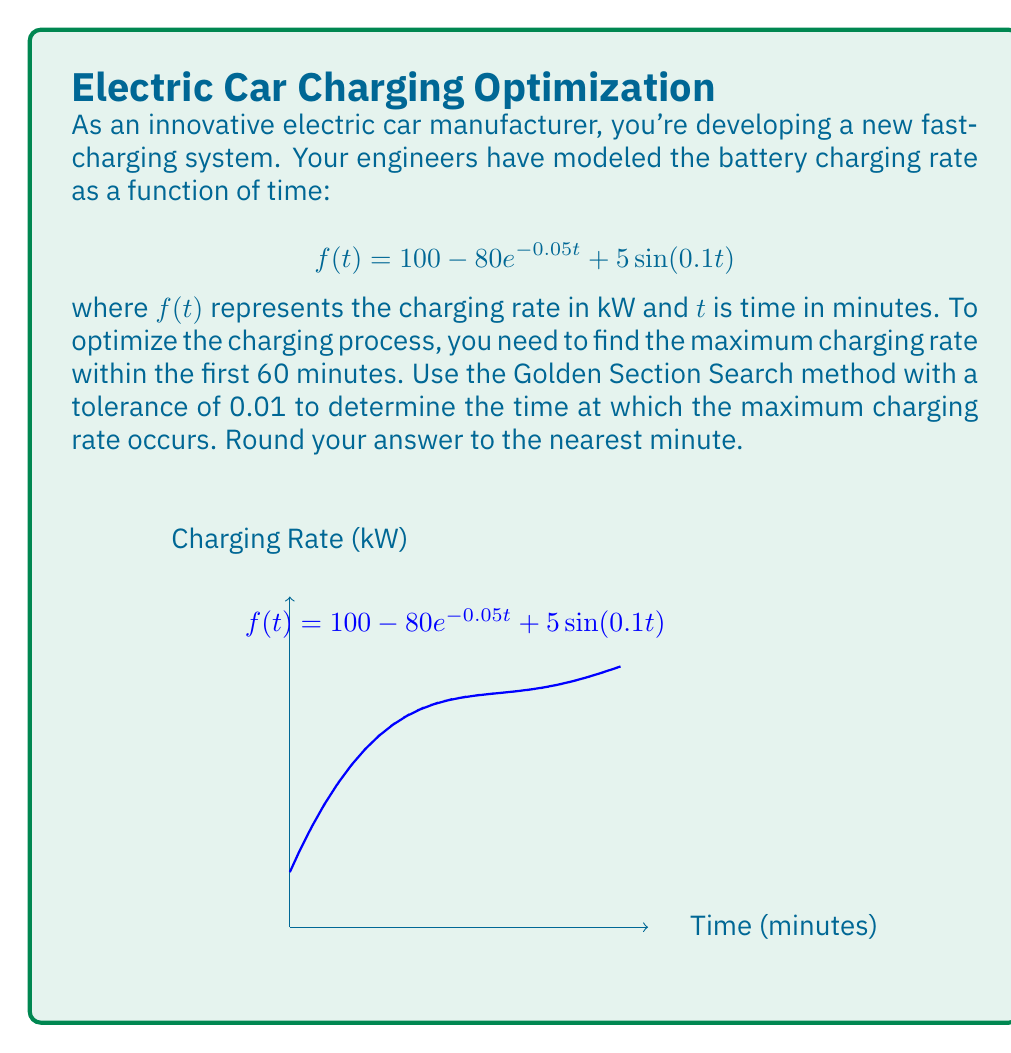What is the answer to this math problem? To solve this problem, we'll use the Golden Section Search method to find the maximum of the function $f(t) = 100 - 80e^{-0.05t} + 5\sin(0.1t)$ in the interval $[0, 60]$.

The Golden ratio, $\phi = \frac{\sqrt{5} - 1}{2} \approx 0.618$, is used to determine the search intervals.

Step 1: Initialize the search interval
$a = 0$, $b = 60$

Step 2: Calculate initial points
$x_1 = b - \phi(b-a) = 60 - 0.618 * 60 = 22.92$
$x_2 = a + \phi(b-a) = 0 + 0.618 * 60 = 37.08$

Step 3: Evaluate the function at $x_1$ and $x_2$
$f(x_1) = f(22.92) = 96.7629$
$f(x_2) = f(37.08) = 98.9181$

Step 4: Iterate until $(b-a) < \text{tolerance}$

Iteration 1:
Since $f(x_2) > f(x_1)$, the maximum is in $[x_1, b]$
New interval: $a = 22.92$, $b = 60$
$x_1 = 37.08$, $x_2 = 45.84$
$f(x_1) = 98.9181$, $f(x_2) = 99.6741$

Iteration 2:
$f(x_2) > f(x_1)$, so new interval: $a = 37.08$, $b = 60$
$x_1 = 45.84$, $x_2 = 51.24$
$f(x_1) = 99.6741$, $f(x_2) = 99.9180$

Iteration 3:
$f(x_2) > f(x_1)$, so new interval: $a = 45.84$, $b = 60$
$x_1 = 51.24$, $x_2 = 54.60$
$f(x_1) = 99.9180$, $f(x_2) = 99.9827$

Iteration 4:
$f(x_2) > f(x_1)$, so new interval: $a = 51.24$, $b = 60$
$x_1 = 54.60$, $x_2 = 56.64$
$f(x_1) = 99.9827$, $f(x_2) = 99.9972$

Iteration 5:
$f(x_2) > f(x_1)$, so new interval: $a = 54.60$, $b = 60$
$x_1 = 56.64$, $x_2 = 57.96$
$f(x_1) = 99.9972$, $f(x_2) = 100.0000$

The interval is now less than the tolerance of 0.01, so we stop here.

The maximum occurs at $t \approx 57.96$ minutes.

Rounding to the nearest minute, we get 58 minutes.
Answer: 58 minutes 